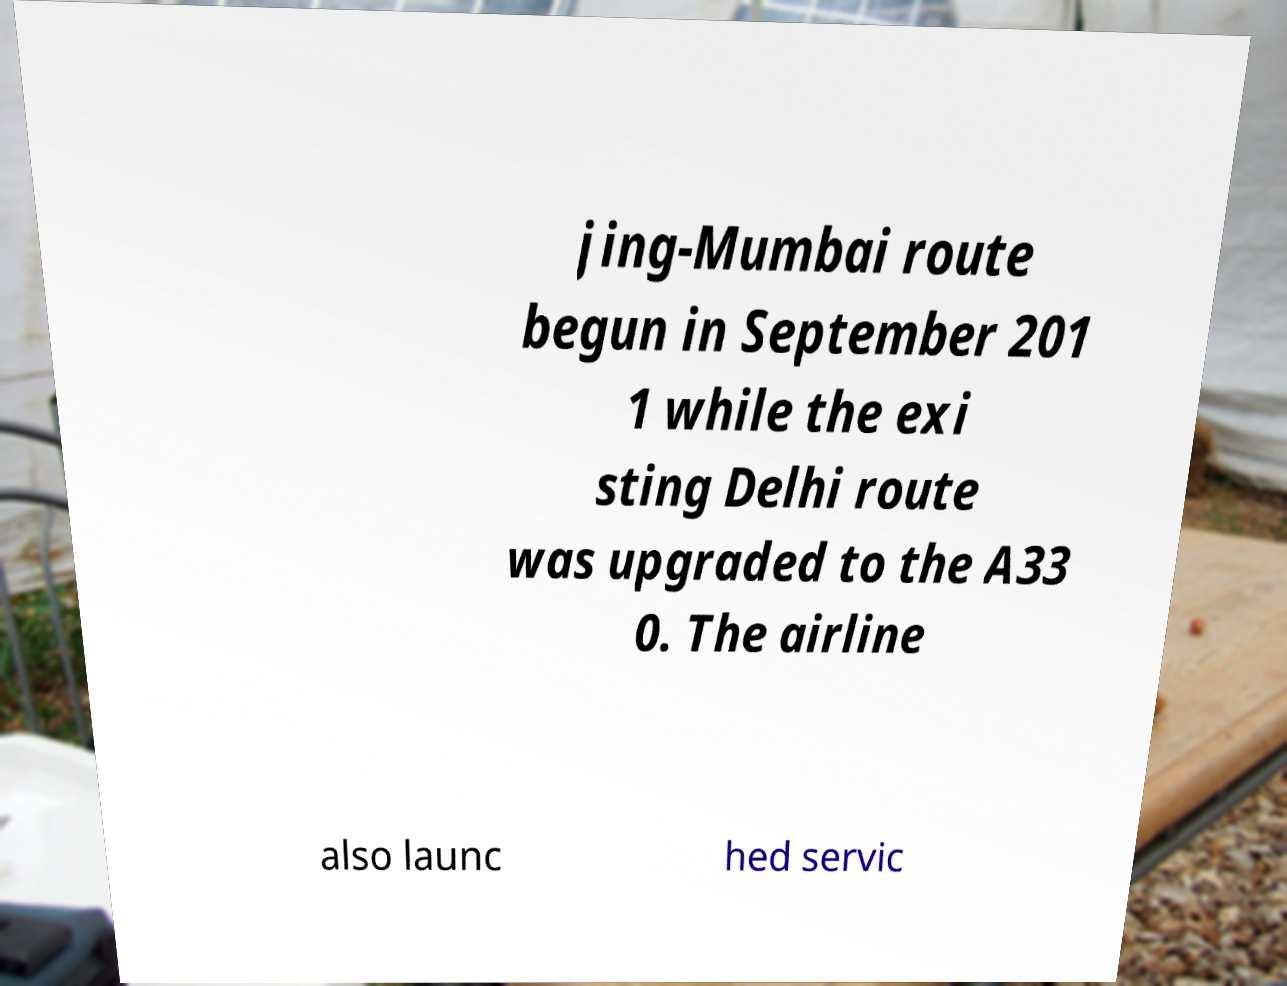Please identify and transcribe the text found in this image. jing-Mumbai route begun in September 201 1 while the exi sting Delhi route was upgraded to the A33 0. The airline also launc hed servic 